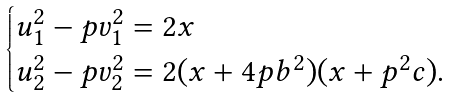Convert formula to latex. <formula><loc_0><loc_0><loc_500><loc_500>\begin{cases} u _ { 1 } ^ { 2 } - p v _ { 1 } ^ { 2 } = 2 x \\ u _ { 2 } ^ { 2 } - p v _ { 2 } ^ { 2 } = 2 ( x + 4 p b ^ { 2 } ) ( x + p ^ { 2 } c ) . \end{cases}</formula> 